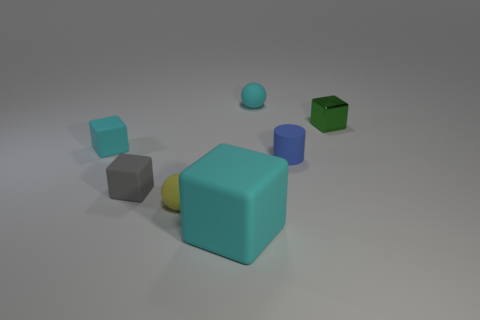Which object in the image is the biggest? The largest object in the image is the cyan rubber cube in the center. Its size dwarfs the other objects when comparing their volumes in the perspective of the image. How can you tell it's the biggest? By observing the relative size and considering the perspective, the cyan cube occupies the most space visually and is bigger than any other individual object in the frame. 